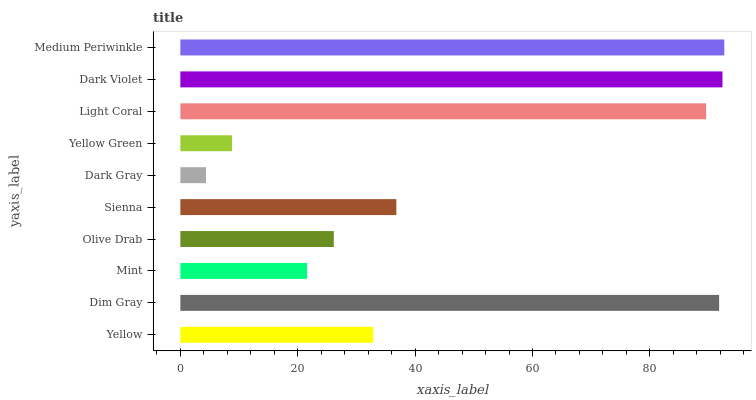Is Dark Gray the minimum?
Answer yes or no. Yes. Is Medium Periwinkle the maximum?
Answer yes or no. Yes. Is Dim Gray the minimum?
Answer yes or no. No. Is Dim Gray the maximum?
Answer yes or no. No. Is Dim Gray greater than Yellow?
Answer yes or no. Yes. Is Yellow less than Dim Gray?
Answer yes or no. Yes. Is Yellow greater than Dim Gray?
Answer yes or no. No. Is Dim Gray less than Yellow?
Answer yes or no. No. Is Sienna the high median?
Answer yes or no. Yes. Is Yellow the low median?
Answer yes or no. Yes. Is Dark Gray the high median?
Answer yes or no. No. Is Olive Drab the low median?
Answer yes or no. No. 